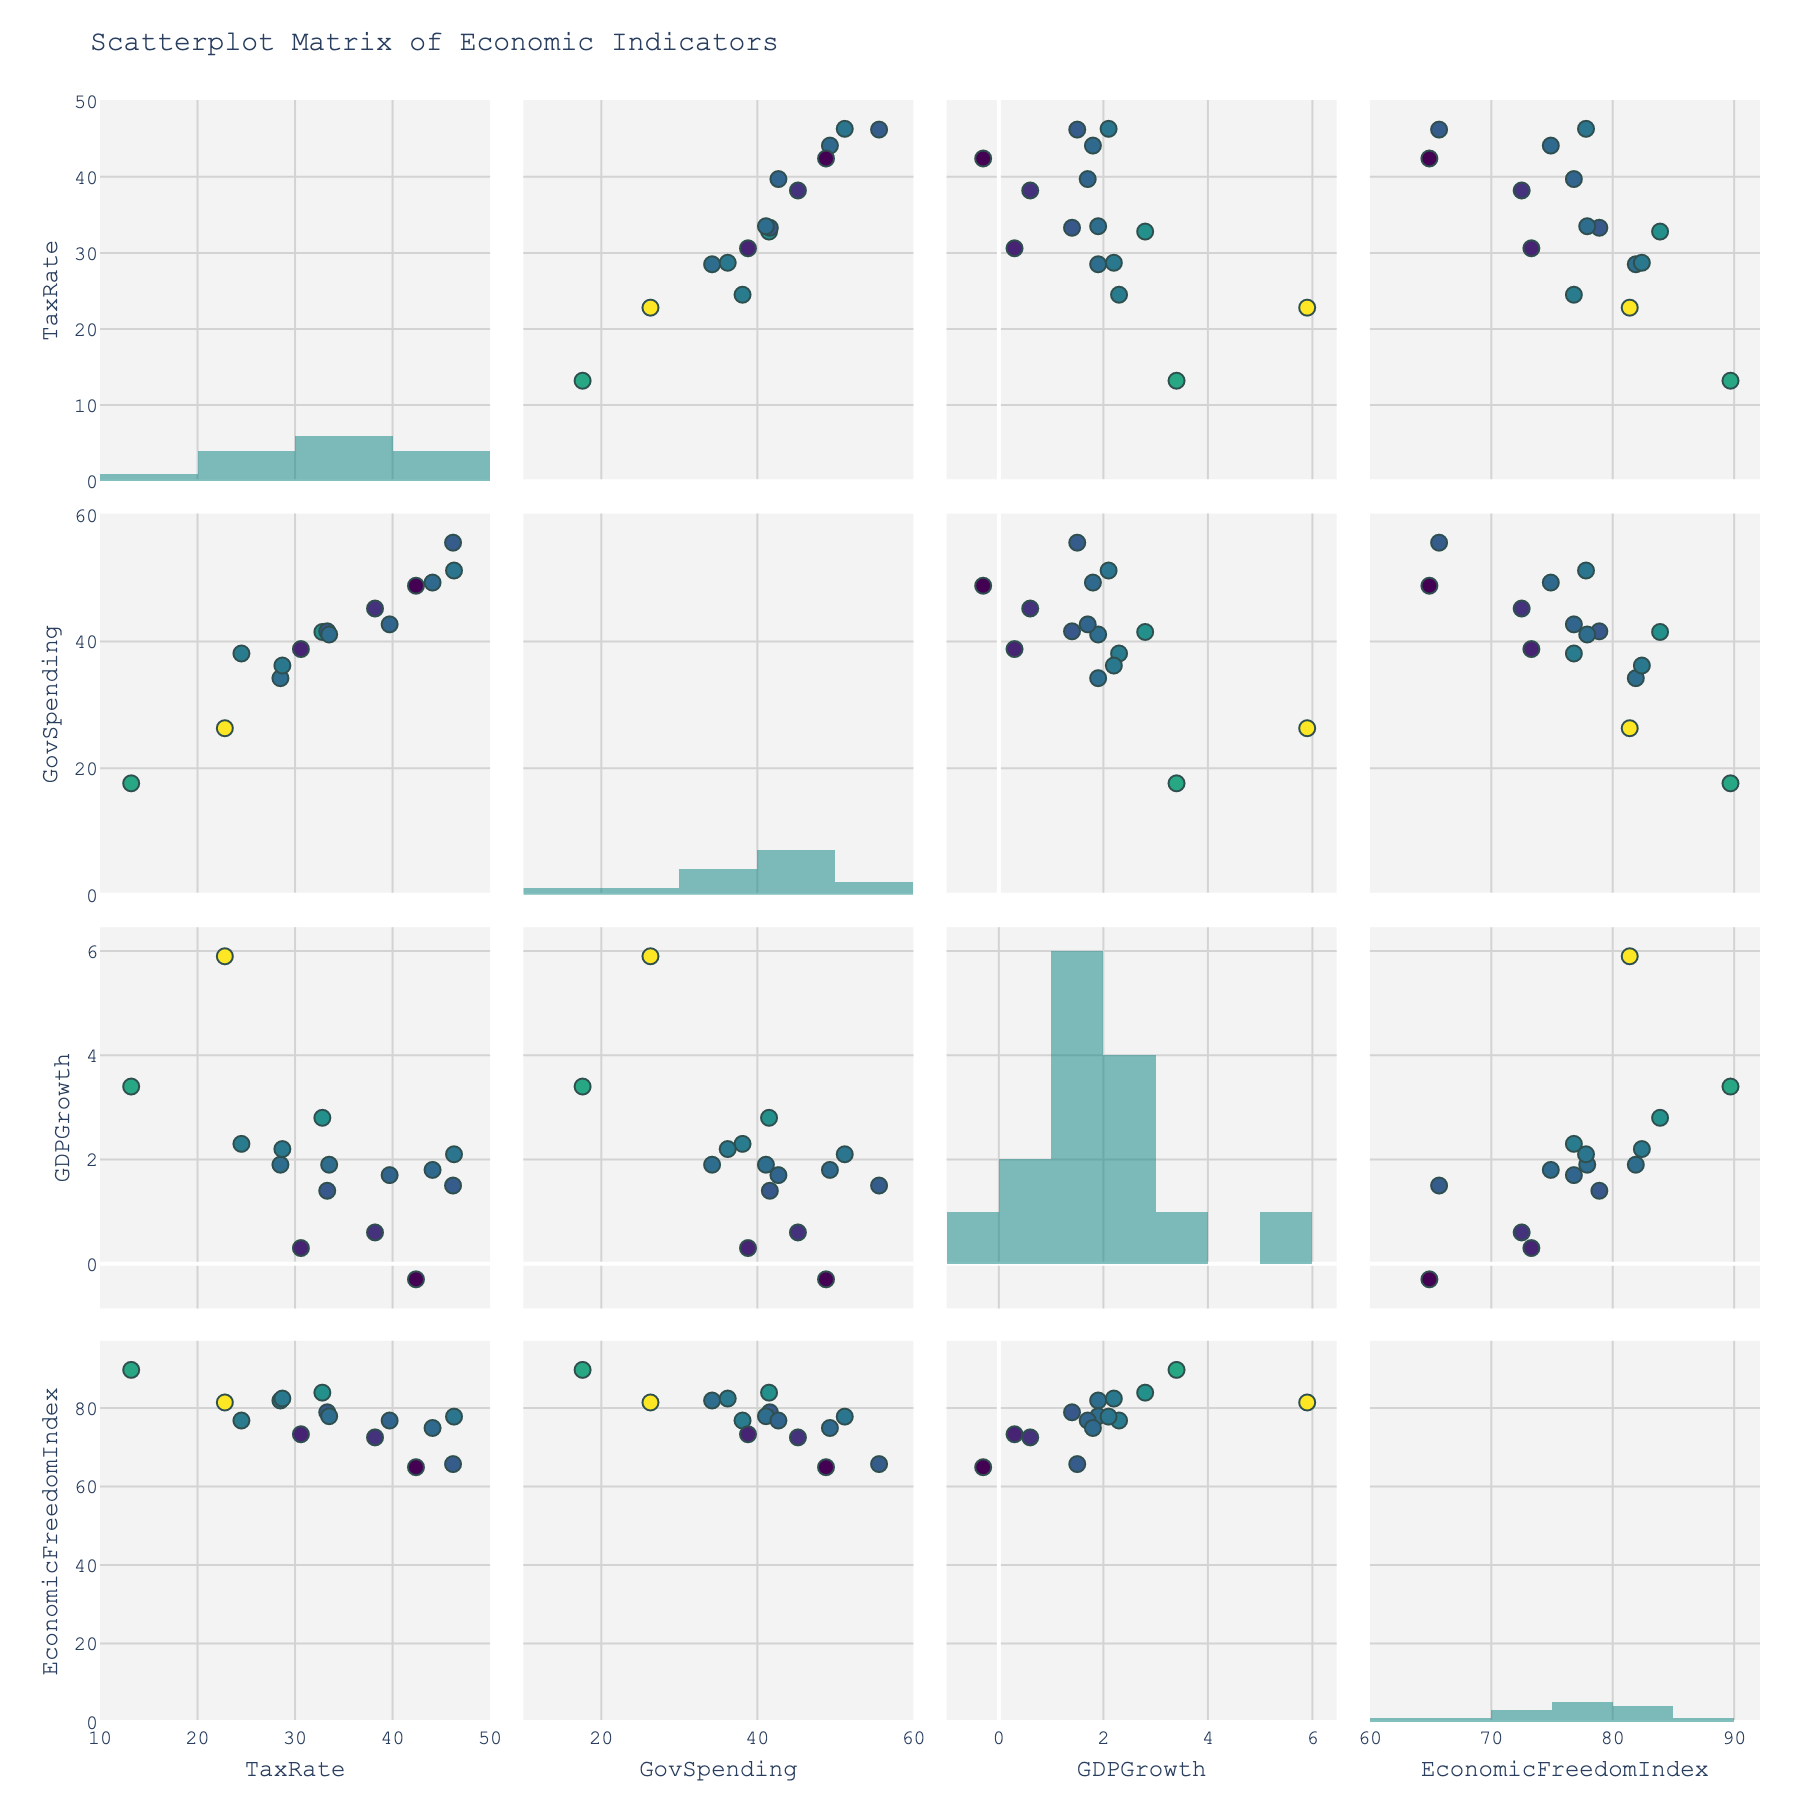How many countries are represented in the figure? Look at the plot and count the number of unique data points (markers) present across the various scatterplots. Each marker represents a different country.
Answer: 15 What is the highest tax rate shown in the histogram on the diagonal? Refer to the histogram plots on the diagonal of the scatterplot matrix. Identify the highest bar in the histogram corresponding to the "TaxRate" variable.
Answer: 46.3 Which country has the highest GDP growth rate and what is the value? Find the marker with the highest value on the "GDPGrowth" axis in the scatterplots, then check the hover info or color coding to identify the country.
Answer: Ireland, 5.9 Is there a general trend between tax rate and economic freedom index? Look at the scatterplot where "TaxRate" is plotted against "EconomicFreedomIndex". Assess whether the points suggest an increasing, decreasing, or no particular trend.
Answer: Decreasing How do government spending and GDP growth relate for Japan? Locate the scatterplot that plots "GovSpending" against "GDPGrowth". Find the marker corresponding to Japan and analyze its position.
Answer: Government spending is high, GDP growth is low Among Denmark, Sweden, and France, which country has the highest government spending? Look at the markers for Denmark, Sweden, and France in the scatterplot where "GovSpending" is plotted on one axis. Compare their positions to identify the highest value.
Answer: France Which country has both high economic freedom and high GDP growth? Check the scatterplot with "EconomicFreedomIndex" on one axis and "GDPGrowth" on the other. Identify the marker in the top-right quadrant which indicates high values for both metrics.
Answer: Ireland What do the colors of the scatterplot markers represent? Look at the color bar or descriptive information around the plot to understand what variable the colors indicate.
Answer: GDP Growth rates Which variable exhibits the highest spread in its histogram? Compare the ranges and variances visually among the histograms on the diagonal. Identify which histogram has the widest spread.
Answer: EconomicFreedomIndex Are higher government spending countries generally having a lower GDP growth? Refer to the scatterplot with "GovSpending" on the x-axis and "GDPGrowth" on the y-axis. Identify if markers generally trend from higher on the left to lower on the right.
Answer: Yes 